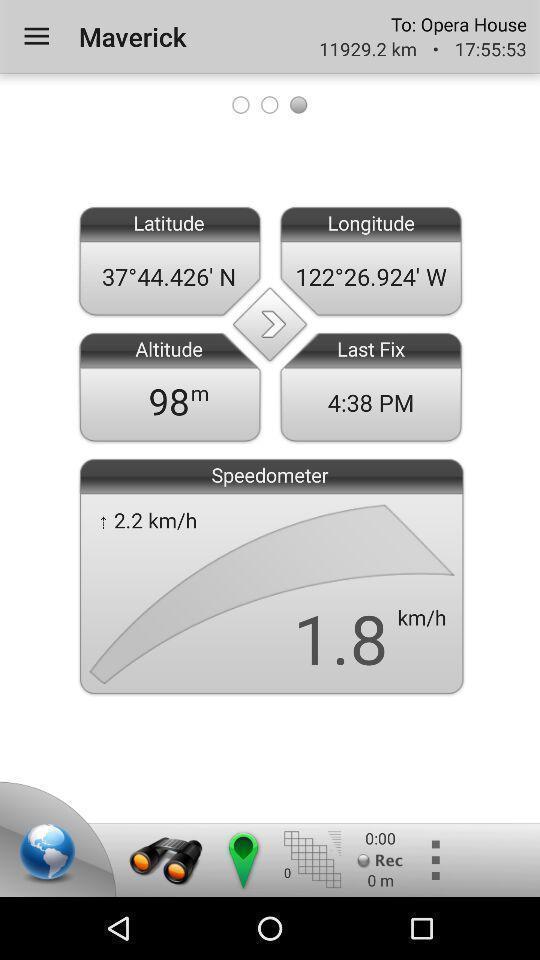Provide a description of this screenshot. Screen shows latitude and longitude details in a navigation app. 